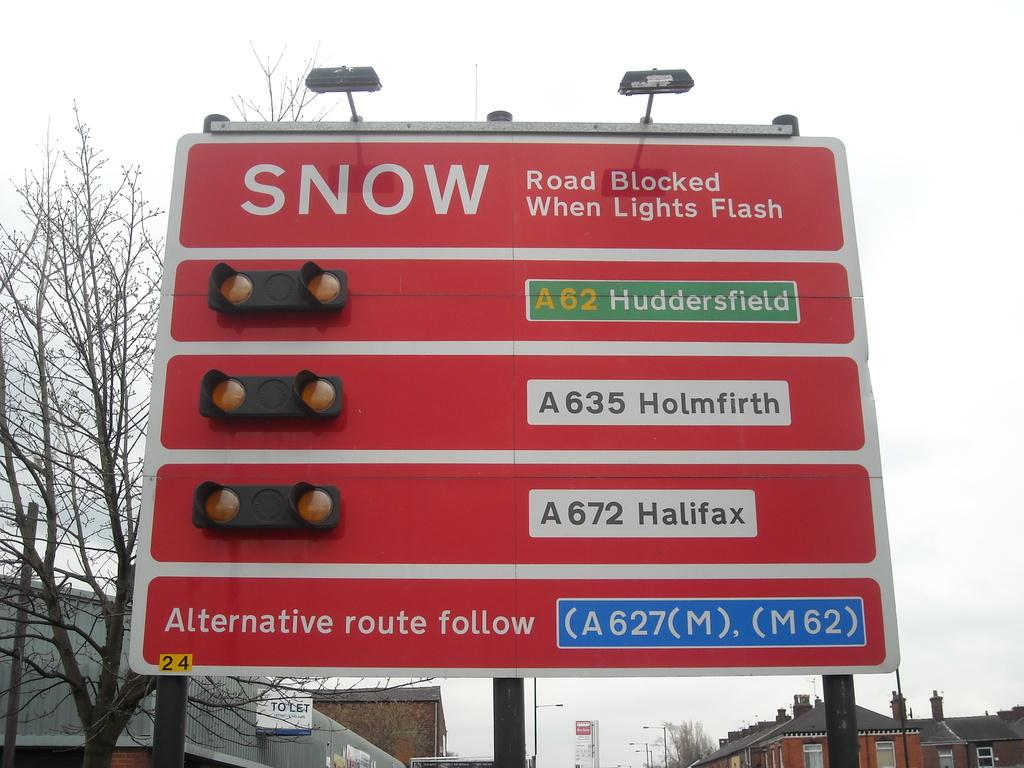<image>
Share a concise interpretation of the image provided. A road sign shows a warning of snow across 3 thruways. 